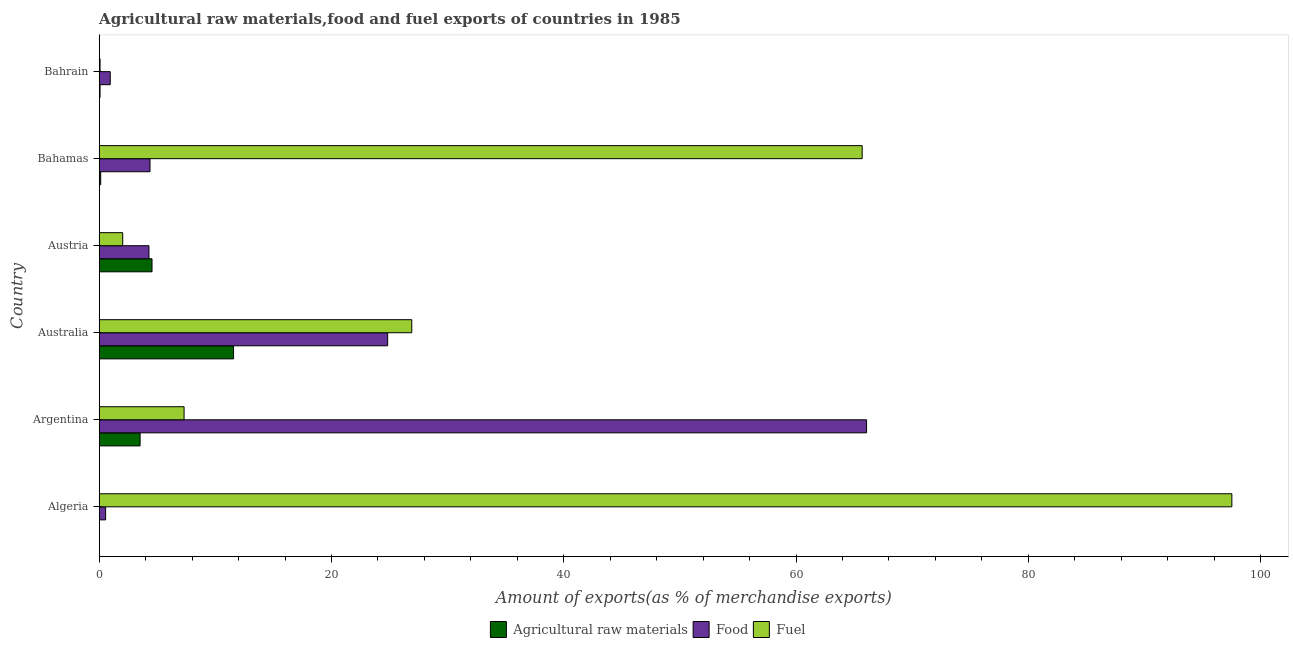How many bars are there on the 4th tick from the top?
Offer a terse response. 3. How many bars are there on the 4th tick from the bottom?
Offer a terse response. 3. What is the label of the 1st group of bars from the top?
Provide a short and direct response. Bahrain. What is the percentage of fuel exports in Australia?
Make the answer very short. 26.91. Across all countries, what is the maximum percentage of raw materials exports?
Your answer should be very brief. 11.57. Across all countries, what is the minimum percentage of raw materials exports?
Offer a terse response. 0.02. In which country was the percentage of fuel exports maximum?
Ensure brevity in your answer.  Algeria. In which country was the percentage of raw materials exports minimum?
Offer a terse response. Algeria. What is the total percentage of fuel exports in the graph?
Offer a very short reply. 199.53. What is the difference between the percentage of food exports in Australia and that in Bahrain?
Offer a very short reply. 23.89. What is the difference between the percentage of food exports in Argentina and the percentage of fuel exports in Bahamas?
Offer a terse response. 0.38. What is the average percentage of raw materials exports per country?
Make the answer very short. 3.31. What is the difference between the percentage of food exports and percentage of fuel exports in Algeria?
Ensure brevity in your answer.  -96.97. In how many countries, is the percentage of raw materials exports greater than 12 %?
Provide a succinct answer. 0. What is the ratio of the percentage of food exports in Bahamas to that in Bahrain?
Give a very brief answer. 4.61. What is the difference between the highest and the second highest percentage of raw materials exports?
Ensure brevity in your answer.  7.02. What is the difference between the highest and the lowest percentage of raw materials exports?
Your answer should be very brief. 11.55. What does the 2nd bar from the top in Argentina represents?
Make the answer very short. Food. What does the 3rd bar from the bottom in Algeria represents?
Your answer should be compact. Fuel. How many bars are there?
Offer a very short reply. 18. Are all the bars in the graph horizontal?
Provide a succinct answer. Yes. How many countries are there in the graph?
Offer a very short reply. 6. What is the difference between two consecutive major ticks on the X-axis?
Provide a short and direct response. 20. Are the values on the major ticks of X-axis written in scientific E-notation?
Provide a succinct answer. No. Does the graph contain any zero values?
Provide a short and direct response. No. Does the graph contain grids?
Give a very brief answer. No. What is the title of the graph?
Your answer should be very brief. Agricultural raw materials,food and fuel exports of countries in 1985. What is the label or title of the X-axis?
Offer a terse response. Amount of exports(as % of merchandise exports). What is the Amount of exports(as % of merchandise exports) of Agricultural raw materials in Algeria?
Offer a terse response. 0.02. What is the Amount of exports(as % of merchandise exports) in Food in Algeria?
Ensure brevity in your answer.  0.55. What is the Amount of exports(as % of merchandise exports) in Fuel in Algeria?
Give a very brief answer. 97.52. What is the Amount of exports(as % of merchandise exports) in Agricultural raw materials in Argentina?
Your answer should be very brief. 3.52. What is the Amount of exports(as % of merchandise exports) of Food in Argentina?
Keep it short and to the point. 66.07. What is the Amount of exports(as % of merchandise exports) of Fuel in Argentina?
Provide a short and direct response. 7.31. What is the Amount of exports(as % of merchandise exports) in Agricultural raw materials in Australia?
Offer a terse response. 11.57. What is the Amount of exports(as % of merchandise exports) in Food in Australia?
Offer a terse response. 24.83. What is the Amount of exports(as % of merchandise exports) of Fuel in Australia?
Make the answer very short. 26.91. What is the Amount of exports(as % of merchandise exports) in Agricultural raw materials in Austria?
Make the answer very short. 4.55. What is the Amount of exports(as % of merchandise exports) in Food in Austria?
Your response must be concise. 4.28. What is the Amount of exports(as % of merchandise exports) of Fuel in Austria?
Offer a very short reply. 2.02. What is the Amount of exports(as % of merchandise exports) in Agricultural raw materials in Bahamas?
Ensure brevity in your answer.  0.13. What is the Amount of exports(as % of merchandise exports) in Food in Bahamas?
Keep it short and to the point. 4.37. What is the Amount of exports(as % of merchandise exports) of Fuel in Bahamas?
Your answer should be compact. 65.69. What is the Amount of exports(as % of merchandise exports) of Agricultural raw materials in Bahrain?
Provide a succinct answer. 0.07. What is the Amount of exports(as % of merchandise exports) of Food in Bahrain?
Provide a succinct answer. 0.95. What is the Amount of exports(as % of merchandise exports) of Fuel in Bahrain?
Offer a very short reply. 0.07. Across all countries, what is the maximum Amount of exports(as % of merchandise exports) of Agricultural raw materials?
Offer a terse response. 11.57. Across all countries, what is the maximum Amount of exports(as % of merchandise exports) of Food?
Your response must be concise. 66.07. Across all countries, what is the maximum Amount of exports(as % of merchandise exports) of Fuel?
Provide a succinct answer. 97.52. Across all countries, what is the minimum Amount of exports(as % of merchandise exports) of Agricultural raw materials?
Offer a very short reply. 0.02. Across all countries, what is the minimum Amount of exports(as % of merchandise exports) in Food?
Keep it short and to the point. 0.55. Across all countries, what is the minimum Amount of exports(as % of merchandise exports) of Fuel?
Ensure brevity in your answer.  0.07. What is the total Amount of exports(as % of merchandise exports) in Agricultural raw materials in the graph?
Make the answer very short. 19.85. What is the total Amount of exports(as % of merchandise exports) of Food in the graph?
Offer a very short reply. 101.06. What is the total Amount of exports(as % of merchandise exports) in Fuel in the graph?
Provide a short and direct response. 199.53. What is the difference between the Amount of exports(as % of merchandise exports) of Agricultural raw materials in Algeria and that in Argentina?
Your answer should be compact. -3.5. What is the difference between the Amount of exports(as % of merchandise exports) in Food in Algeria and that in Argentina?
Offer a very short reply. -65.52. What is the difference between the Amount of exports(as % of merchandise exports) in Fuel in Algeria and that in Argentina?
Make the answer very short. 90.22. What is the difference between the Amount of exports(as % of merchandise exports) of Agricultural raw materials in Algeria and that in Australia?
Offer a very short reply. -11.55. What is the difference between the Amount of exports(as % of merchandise exports) of Food in Algeria and that in Australia?
Your answer should be compact. -24.28. What is the difference between the Amount of exports(as % of merchandise exports) of Fuel in Algeria and that in Australia?
Give a very brief answer. 70.61. What is the difference between the Amount of exports(as % of merchandise exports) in Agricultural raw materials in Algeria and that in Austria?
Offer a very short reply. -4.53. What is the difference between the Amount of exports(as % of merchandise exports) in Food in Algeria and that in Austria?
Make the answer very short. -3.73. What is the difference between the Amount of exports(as % of merchandise exports) in Fuel in Algeria and that in Austria?
Offer a very short reply. 95.5. What is the difference between the Amount of exports(as % of merchandise exports) in Agricultural raw materials in Algeria and that in Bahamas?
Ensure brevity in your answer.  -0.11. What is the difference between the Amount of exports(as % of merchandise exports) of Food in Algeria and that in Bahamas?
Give a very brief answer. -3.82. What is the difference between the Amount of exports(as % of merchandise exports) of Fuel in Algeria and that in Bahamas?
Keep it short and to the point. 31.83. What is the difference between the Amount of exports(as % of merchandise exports) of Agricultural raw materials in Algeria and that in Bahrain?
Provide a succinct answer. -0.05. What is the difference between the Amount of exports(as % of merchandise exports) in Food in Algeria and that in Bahrain?
Ensure brevity in your answer.  -0.4. What is the difference between the Amount of exports(as % of merchandise exports) in Fuel in Algeria and that in Bahrain?
Offer a terse response. 97.45. What is the difference between the Amount of exports(as % of merchandise exports) of Agricultural raw materials in Argentina and that in Australia?
Offer a very short reply. -8.05. What is the difference between the Amount of exports(as % of merchandise exports) in Food in Argentina and that in Australia?
Offer a terse response. 41.24. What is the difference between the Amount of exports(as % of merchandise exports) in Fuel in Argentina and that in Australia?
Offer a terse response. -19.6. What is the difference between the Amount of exports(as % of merchandise exports) in Agricultural raw materials in Argentina and that in Austria?
Provide a succinct answer. -1.03. What is the difference between the Amount of exports(as % of merchandise exports) of Food in Argentina and that in Austria?
Your answer should be very brief. 61.79. What is the difference between the Amount of exports(as % of merchandise exports) in Fuel in Argentina and that in Austria?
Give a very brief answer. 5.28. What is the difference between the Amount of exports(as % of merchandise exports) in Agricultural raw materials in Argentina and that in Bahamas?
Provide a short and direct response. 3.39. What is the difference between the Amount of exports(as % of merchandise exports) of Food in Argentina and that in Bahamas?
Your response must be concise. 61.7. What is the difference between the Amount of exports(as % of merchandise exports) of Fuel in Argentina and that in Bahamas?
Give a very brief answer. -58.39. What is the difference between the Amount of exports(as % of merchandise exports) of Agricultural raw materials in Argentina and that in Bahrain?
Your answer should be compact. 3.45. What is the difference between the Amount of exports(as % of merchandise exports) in Food in Argentina and that in Bahrain?
Ensure brevity in your answer.  65.12. What is the difference between the Amount of exports(as % of merchandise exports) in Fuel in Argentina and that in Bahrain?
Ensure brevity in your answer.  7.23. What is the difference between the Amount of exports(as % of merchandise exports) in Agricultural raw materials in Australia and that in Austria?
Your response must be concise. 7.02. What is the difference between the Amount of exports(as % of merchandise exports) in Food in Australia and that in Austria?
Provide a succinct answer. 20.55. What is the difference between the Amount of exports(as % of merchandise exports) in Fuel in Australia and that in Austria?
Your answer should be very brief. 24.89. What is the difference between the Amount of exports(as % of merchandise exports) in Agricultural raw materials in Australia and that in Bahamas?
Give a very brief answer. 11.44. What is the difference between the Amount of exports(as % of merchandise exports) in Food in Australia and that in Bahamas?
Provide a short and direct response. 20.46. What is the difference between the Amount of exports(as % of merchandise exports) of Fuel in Australia and that in Bahamas?
Your answer should be compact. -38.78. What is the difference between the Amount of exports(as % of merchandise exports) of Agricultural raw materials in Australia and that in Bahrain?
Your answer should be compact. 11.5. What is the difference between the Amount of exports(as % of merchandise exports) of Food in Australia and that in Bahrain?
Offer a terse response. 23.89. What is the difference between the Amount of exports(as % of merchandise exports) in Fuel in Australia and that in Bahrain?
Your response must be concise. 26.84. What is the difference between the Amount of exports(as % of merchandise exports) in Agricultural raw materials in Austria and that in Bahamas?
Your answer should be very brief. 4.42. What is the difference between the Amount of exports(as % of merchandise exports) in Food in Austria and that in Bahamas?
Offer a terse response. -0.09. What is the difference between the Amount of exports(as % of merchandise exports) of Fuel in Austria and that in Bahamas?
Your answer should be very brief. -63.67. What is the difference between the Amount of exports(as % of merchandise exports) of Agricultural raw materials in Austria and that in Bahrain?
Keep it short and to the point. 4.48. What is the difference between the Amount of exports(as % of merchandise exports) in Food in Austria and that in Bahrain?
Your answer should be very brief. 3.33. What is the difference between the Amount of exports(as % of merchandise exports) of Fuel in Austria and that in Bahrain?
Offer a very short reply. 1.95. What is the difference between the Amount of exports(as % of merchandise exports) in Agricultural raw materials in Bahamas and that in Bahrain?
Offer a terse response. 0.06. What is the difference between the Amount of exports(as % of merchandise exports) in Food in Bahamas and that in Bahrain?
Keep it short and to the point. 3.42. What is the difference between the Amount of exports(as % of merchandise exports) in Fuel in Bahamas and that in Bahrain?
Offer a very short reply. 65.62. What is the difference between the Amount of exports(as % of merchandise exports) of Agricultural raw materials in Algeria and the Amount of exports(as % of merchandise exports) of Food in Argentina?
Offer a very short reply. -66.05. What is the difference between the Amount of exports(as % of merchandise exports) of Agricultural raw materials in Algeria and the Amount of exports(as % of merchandise exports) of Fuel in Argentina?
Ensure brevity in your answer.  -7.29. What is the difference between the Amount of exports(as % of merchandise exports) in Food in Algeria and the Amount of exports(as % of merchandise exports) in Fuel in Argentina?
Make the answer very short. -6.76. What is the difference between the Amount of exports(as % of merchandise exports) in Agricultural raw materials in Algeria and the Amount of exports(as % of merchandise exports) in Food in Australia?
Your answer should be compact. -24.82. What is the difference between the Amount of exports(as % of merchandise exports) in Agricultural raw materials in Algeria and the Amount of exports(as % of merchandise exports) in Fuel in Australia?
Your answer should be very brief. -26.89. What is the difference between the Amount of exports(as % of merchandise exports) of Food in Algeria and the Amount of exports(as % of merchandise exports) of Fuel in Australia?
Provide a short and direct response. -26.36. What is the difference between the Amount of exports(as % of merchandise exports) in Agricultural raw materials in Algeria and the Amount of exports(as % of merchandise exports) in Food in Austria?
Your response must be concise. -4.27. What is the difference between the Amount of exports(as % of merchandise exports) in Agricultural raw materials in Algeria and the Amount of exports(as % of merchandise exports) in Fuel in Austria?
Offer a very short reply. -2.01. What is the difference between the Amount of exports(as % of merchandise exports) of Food in Algeria and the Amount of exports(as % of merchandise exports) of Fuel in Austria?
Keep it short and to the point. -1.47. What is the difference between the Amount of exports(as % of merchandise exports) of Agricultural raw materials in Algeria and the Amount of exports(as % of merchandise exports) of Food in Bahamas?
Your answer should be very brief. -4.36. What is the difference between the Amount of exports(as % of merchandise exports) of Agricultural raw materials in Algeria and the Amount of exports(as % of merchandise exports) of Fuel in Bahamas?
Keep it short and to the point. -65.68. What is the difference between the Amount of exports(as % of merchandise exports) in Food in Algeria and the Amount of exports(as % of merchandise exports) in Fuel in Bahamas?
Ensure brevity in your answer.  -65.14. What is the difference between the Amount of exports(as % of merchandise exports) in Agricultural raw materials in Algeria and the Amount of exports(as % of merchandise exports) in Food in Bahrain?
Make the answer very short. -0.93. What is the difference between the Amount of exports(as % of merchandise exports) in Agricultural raw materials in Algeria and the Amount of exports(as % of merchandise exports) in Fuel in Bahrain?
Give a very brief answer. -0.06. What is the difference between the Amount of exports(as % of merchandise exports) of Food in Algeria and the Amount of exports(as % of merchandise exports) of Fuel in Bahrain?
Give a very brief answer. 0.48. What is the difference between the Amount of exports(as % of merchandise exports) of Agricultural raw materials in Argentina and the Amount of exports(as % of merchandise exports) of Food in Australia?
Make the answer very short. -21.32. What is the difference between the Amount of exports(as % of merchandise exports) in Agricultural raw materials in Argentina and the Amount of exports(as % of merchandise exports) in Fuel in Australia?
Give a very brief answer. -23.39. What is the difference between the Amount of exports(as % of merchandise exports) in Food in Argentina and the Amount of exports(as % of merchandise exports) in Fuel in Australia?
Provide a short and direct response. 39.16. What is the difference between the Amount of exports(as % of merchandise exports) of Agricultural raw materials in Argentina and the Amount of exports(as % of merchandise exports) of Food in Austria?
Give a very brief answer. -0.77. What is the difference between the Amount of exports(as % of merchandise exports) of Agricultural raw materials in Argentina and the Amount of exports(as % of merchandise exports) of Fuel in Austria?
Your answer should be very brief. 1.5. What is the difference between the Amount of exports(as % of merchandise exports) of Food in Argentina and the Amount of exports(as % of merchandise exports) of Fuel in Austria?
Make the answer very short. 64.05. What is the difference between the Amount of exports(as % of merchandise exports) in Agricultural raw materials in Argentina and the Amount of exports(as % of merchandise exports) in Food in Bahamas?
Make the answer very short. -0.85. What is the difference between the Amount of exports(as % of merchandise exports) of Agricultural raw materials in Argentina and the Amount of exports(as % of merchandise exports) of Fuel in Bahamas?
Provide a succinct answer. -62.17. What is the difference between the Amount of exports(as % of merchandise exports) in Food in Argentina and the Amount of exports(as % of merchandise exports) in Fuel in Bahamas?
Your response must be concise. 0.38. What is the difference between the Amount of exports(as % of merchandise exports) of Agricultural raw materials in Argentina and the Amount of exports(as % of merchandise exports) of Food in Bahrain?
Offer a terse response. 2.57. What is the difference between the Amount of exports(as % of merchandise exports) in Agricultural raw materials in Argentina and the Amount of exports(as % of merchandise exports) in Fuel in Bahrain?
Your answer should be very brief. 3.45. What is the difference between the Amount of exports(as % of merchandise exports) in Food in Argentina and the Amount of exports(as % of merchandise exports) in Fuel in Bahrain?
Provide a short and direct response. 66. What is the difference between the Amount of exports(as % of merchandise exports) of Agricultural raw materials in Australia and the Amount of exports(as % of merchandise exports) of Food in Austria?
Give a very brief answer. 7.28. What is the difference between the Amount of exports(as % of merchandise exports) of Agricultural raw materials in Australia and the Amount of exports(as % of merchandise exports) of Fuel in Austria?
Give a very brief answer. 9.55. What is the difference between the Amount of exports(as % of merchandise exports) of Food in Australia and the Amount of exports(as % of merchandise exports) of Fuel in Austria?
Offer a very short reply. 22.81. What is the difference between the Amount of exports(as % of merchandise exports) in Agricultural raw materials in Australia and the Amount of exports(as % of merchandise exports) in Food in Bahamas?
Offer a terse response. 7.19. What is the difference between the Amount of exports(as % of merchandise exports) in Agricultural raw materials in Australia and the Amount of exports(as % of merchandise exports) in Fuel in Bahamas?
Keep it short and to the point. -54.12. What is the difference between the Amount of exports(as % of merchandise exports) in Food in Australia and the Amount of exports(as % of merchandise exports) in Fuel in Bahamas?
Your answer should be very brief. -40.86. What is the difference between the Amount of exports(as % of merchandise exports) of Agricultural raw materials in Australia and the Amount of exports(as % of merchandise exports) of Food in Bahrain?
Make the answer very short. 10.62. What is the difference between the Amount of exports(as % of merchandise exports) of Agricultural raw materials in Australia and the Amount of exports(as % of merchandise exports) of Fuel in Bahrain?
Make the answer very short. 11.49. What is the difference between the Amount of exports(as % of merchandise exports) of Food in Australia and the Amount of exports(as % of merchandise exports) of Fuel in Bahrain?
Your answer should be very brief. 24.76. What is the difference between the Amount of exports(as % of merchandise exports) in Agricultural raw materials in Austria and the Amount of exports(as % of merchandise exports) in Food in Bahamas?
Keep it short and to the point. 0.17. What is the difference between the Amount of exports(as % of merchandise exports) of Agricultural raw materials in Austria and the Amount of exports(as % of merchandise exports) of Fuel in Bahamas?
Give a very brief answer. -61.15. What is the difference between the Amount of exports(as % of merchandise exports) in Food in Austria and the Amount of exports(as % of merchandise exports) in Fuel in Bahamas?
Give a very brief answer. -61.41. What is the difference between the Amount of exports(as % of merchandise exports) in Agricultural raw materials in Austria and the Amount of exports(as % of merchandise exports) in Food in Bahrain?
Make the answer very short. 3.6. What is the difference between the Amount of exports(as % of merchandise exports) of Agricultural raw materials in Austria and the Amount of exports(as % of merchandise exports) of Fuel in Bahrain?
Your response must be concise. 4.47. What is the difference between the Amount of exports(as % of merchandise exports) of Food in Austria and the Amount of exports(as % of merchandise exports) of Fuel in Bahrain?
Provide a short and direct response. 4.21. What is the difference between the Amount of exports(as % of merchandise exports) in Agricultural raw materials in Bahamas and the Amount of exports(as % of merchandise exports) in Food in Bahrain?
Your answer should be compact. -0.82. What is the difference between the Amount of exports(as % of merchandise exports) of Agricultural raw materials in Bahamas and the Amount of exports(as % of merchandise exports) of Fuel in Bahrain?
Your response must be concise. 0.05. What is the average Amount of exports(as % of merchandise exports) of Agricultural raw materials per country?
Offer a terse response. 3.31. What is the average Amount of exports(as % of merchandise exports) of Food per country?
Your answer should be compact. 16.84. What is the average Amount of exports(as % of merchandise exports) of Fuel per country?
Your answer should be compact. 33.25. What is the difference between the Amount of exports(as % of merchandise exports) in Agricultural raw materials and Amount of exports(as % of merchandise exports) in Food in Algeria?
Provide a short and direct response. -0.53. What is the difference between the Amount of exports(as % of merchandise exports) of Agricultural raw materials and Amount of exports(as % of merchandise exports) of Fuel in Algeria?
Ensure brevity in your answer.  -97.51. What is the difference between the Amount of exports(as % of merchandise exports) in Food and Amount of exports(as % of merchandise exports) in Fuel in Algeria?
Provide a succinct answer. -96.97. What is the difference between the Amount of exports(as % of merchandise exports) in Agricultural raw materials and Amount of exports(as % of merchandise exports) in Food in Argentina?
Keep it short and to the point. -62.55. What is the difference between the Amount of exports(as % of merchandise exports) in Agricultural raw materials and Amount of exports(as % of merchandise exports) in Fuel in Argentina?
Your answer should be very brief. -3.79. What is the difference between the Amount of exports(as % of merchandise exports) in Food and Amount of exports(as % of merchandise exports) in Fuel in Argentina?
Provide a short and direct response. 58.76. What is the difference between the Amount of exports(as % of merchandise exports) of Agricultural raw materials and Amount of exports(as % of merchandise exports) of Food in Australia?
Your answer should be compact. -13.27. What is the difference between the Amount of exports(as % of merchandise exports) of Agricultural raw materials and Amount of exports(as % of merchandise exports) of Fuel in Australia?
Offer a terse response. -15.34. What is the difference between the Amount of exports(as % of merchandise exports) in Food and Amount of exports(as % of merchandise exports) in Fuel in Australia?
Ensure brevity in your answer.  -2.08. What is the difference between the Amount of exports(as % of merchandise exports) in Agricultural raw materials and Amount of exports(as % of merchandise exports) in Food in Austria?
Offer a terse response. 0.26. What is the difference between the Amount of exports(as % of merchandise exports) in Agricultural raw materials and Amount of exports(as % of merchandise exports) in Fuel in Austria?
Provide a short and direct response. 2.52. What is the difference between the Amount of exports(as % of merchandise exports) of Food and Amount of exports(as % of merchandise exports) of Fuel in Austria?
Your response must be concise. 2.26. What is the difference between the Amount of exports(as % of merchandise exports) of Agricultural raw materials and Amount of exports(as % of merchandise exports) of Food in Bahamas?
Your answer should be compact. -4.25. What is the difference between the Amount of exports(as % of merchandise exports) of Agricultural raw materials and Amount of exports(as % of merchandise exports) of Fuel in Bahamas?
Offer a terse response. -65.57. What is the difference between the Amount of exports(as % of merchandise exports) in Food and Amount of exports(as % of merchandise exports) in Fuel in Bahamas?
Your answer should be compact. -61.32. What is the difference between the Amount of exports(as % of merchandise exports) in Agricultural raw materials and Amount of exports(as % of merchandise exports) in Food in Bahrain?
Your answer should be compact. -0.88. What is the difference between the Amount of exports(as % of merchandise exports) in Agricultural raw materials and Amount of exports(as % of merchandise exports) in Fuel in Bahrain?
Your answer should be very brief. -0. What is the difference between the Amount of exports(as % of merchandise exports) of Food and Amount of exports(as % of merchandise exports) of Fuel in Bahrain?
Give a very brief answer. 0.88. What is the ratio of the Amount of exports(as % of merchandise exports) of Agricultural raw materials in Algeria to that in Argentina?
Give a very brief answer. 0. What is the ratio of the Amount of exports(as % of merchandise exports) in Food in Algeria to that in Argentina?
Provide a short and direct response. 0.01. What is the ratio of the Amount of exports(as % of merchandise exports) of Fuel in Algeria to that in Argentina?
Provide a short and direct response. 13.35. What is the ratio of the Amount of exports(as % of merchandise exports) of Agricultural raw materials in Algeria to that in Australia?
Provide a succinct answer. 0. What is the ratio of the Amount of exports(as % of merchandise exports) in Food in Algeria to that in Australia?
Your response must be concise. 0.02. What is the ratio of the Amount of exports(as % of merchandise exports) in Fuel in Algeria to that in Australia?
Your response must be concise. 3.62. What is the ratio of the Amount of exports(as % of merchandise exports) of Agricultural raw materials in Algeria to that in Austria?
Ensure brevity in your answer.  0. What is the ratio of the Amount of exports(as % of merchandise exports) in Food in Algeria to that in Austria?
Provide a short and direct response. 0.13. What is the ratio of the Amount of exports(as % of merchandise exports) of Fuel in Algeria to that in Austria?
Provide a succinct answer. 48.22. What is the ratio of the Amount of exports(as % of merchandise exports) in Agricultural raw materials in Algeria to that in Bahamas?
Offer a very short reply. 0.13. What is the ratio of the Amount of exports(as % of merchandise exports) of Food in Algeria to that in Bahamas?
Your response must be concise. 0.13. What is the ratio of the Amount of exports(as % of merchandise exports) in Fuel in Algeria to that in Bahamas?
Your response must be concise. 1.48. What is the ratio of the Amount of exports(as % of merchandise exports) of Agricultural raw materials in Algeria to that in Bahrain?
Provide a succinct answer. 0.23. What is the ratio of the Amount of exports(as % of merchandise exports) of Food in Algeria to that in Bahrain?
Give a very brief answer. 0.58. What is the ratio of the Amount of exports(as % of merchandise exports) in Fuel in Algeria to that in Bahrain?
Provide a succinct answer. 1343.03. What is the ratio of the Amount of exports(as % of merchandise exports) of Agricultural raw materials in Argentina to that in Australia?
Offer a terse response. 0.3. What is the ratio of the Amount of exports(as % of merchandise exports) in Food in Argentina to that in Australia?
Your answer should be very brief. 2.66. What is the ratio of the Amount of exports(as % of merchandise exports) of Fuel in Argentina to that in Australia?
Offer a very short reply. 0.27. What is the ratio of the Amount of exports(as % of merchandise exports) of Agricultural raw materials in Argentina to that in Austria?
Provide a short and direct response. 0.77. What is the ratio of the Amount of exports(as % of merchandise exports) of Food in Argentina to that in Austria?
Provide a succinct answer. 15.42. What is the ratio of the Amount of exports(as % of merchandise exports) in Fuel in Argentina to that in Austria?
Keep it short and to the point. 3.61. What is the ratio of the Amount of exports(as % of merchandise exports) in Agricultural raw materials in Argentina to that in Bahamas?
Your answer should be compact. 27.75. What is the ratio of the Amount of exports(as % of merchandise exports) of Food in Argentina to that in Bahamas?
Ensure brevity in your answer.  15.11. What is the ratio of the Amount of exports(as % of merchandise exports) of Fuel in Argentina to that in Bahamas?
Make the answer very short. 0.11. What is the ratio of the Amount of exports(as % of merchandise exports) of Agricultural raw materials in Argentina to that in Bahrain?
Ensure brevity in your answer.  49.51. What is the ratio of the Amount of exports(as % of merchandise exports) of Food in Argentina to that in Bahrain?
Provide a succinct answer. 69.6. What is the ratio of the Amount of exports(as % of merchandise exports) of Fuel in Argentina to that in Bahrain?
Provide a succinct answer. 100.63. What is the ratio of the Amount of exports(as % of merchandise exports) in Agricultural raw materials in Australia to that in Austria?
Your answer should be compact. 2.54. What is the ratio of the Amount of exports(as % of merchandise exports) of Food in Australia to that in Austria?
Your answer should be very brief. 5.8. What is the ratio of the Amount of exports(as % of merchandise exports) of Fuel in Australia to that in Austria?
Offer a terse response. 13.31. What is the ratio of the Amount of exports(as % of merchandise exports) of Agricultural raw materials in Australia to that in Bahamas?
Your answer should be very brief. 91.23. What is the ratio of the Amount of exports(as % of merchandise exports) in Food in Australia to that in Bahamas?
Your answer should be compact. 5.68. What is the ratio of the Amount of exports(as % of merchandise exports) of Fuel in Australia to that in Bahamas?
Offer a very short reply. 0.41. What is the ratio of the Amount of exports(as % of merchandise exports) in Agricultural raw materials in Australia to that in Bahrain?
Make the answer very short. 162.76. What is the ratio of the Amount of exports(as % of merchandise exports) in Food in Australia to that in Bahrain?
Your answer should be very brief. 26.16. What is the ratio of the Amount of exports(as % of merchandise exports) in Fuel in Australia to that in Bahrain?
Offer a very short reply. 370.61. What is the ratio of the Amount of exports(as % of merchandise exports) in Agricultural raw materials in Austria to that in Bahamas?
Your response must be concise. 35.86. What is the ratio of the Amount of exports(as % of merchandise exports) of Food in Austria to that in Bahamas?
Provide a short and direct response. 0.98. What is the ratio of the Amount of exports(as % of merchandise exports) in Fuel in Austria to that in Bahamas?
Your answer should be compact. 0.03. What is the ratio of the Amount of exports(as % of merchandise exports) of Agricultural raw materials in Austria to that in Bahrain?
Ensure brevity in your answer.  63.98. What is the ratio of the Amount of exports(as % of merchandise exports) in Food in Austria to that in Bahrain?
Your answer should be very brief. 4.51. What is the ratio of the Amount of exports(as % of merchandise exports) in Fuel in Austria to that in Bahrain?
Keep it short and to the point. 27.85. What is the ratio of the Amount of exports(as % of merchandise exports) of Agricultural raw materials in Bahamas to that in Bahrain?
Offer a terse response. 1.78. What is the ratio of the Amount of exports(as % of merchandise exports) of Food in Bahamas to that in Bahrain?
Your answer should be compact. 4.61. What is the ratio of the Amount of exports(as % of merchandise exports) in Fuel in Bahamas to that in Bahrain?
Provide a succinct answer. 904.68. What is the difference between the highest and the second highest Amount of exports(as % of merchandise exports) of Agricultural raw materials?
Your answer should be very brief. 7.02. What is the difference between the highest and the second highest Amount of exports(as % of merchandise exports) of Food?
Your answer should be compact. 41.24. What is the difference between the highest and the second highest Amount of exports(as % of merchandise exports) in Fuel?
Your answer should be very brief. 31.83. What is the difference between the highest and the lowest Amount of exports(as % of merchandise exports) in Agricultural raw materials?
Offer a very short reply. 11.55. What is the difference between the highest and the lowest Amount of exports(as % of merchandise exports) of Food?
Provide a short and direct response. 65.52. What is the difference between the highest and the lowest Amount of exports(as % of merchandise exports) of Fuel?
Offer a very short reply. 97.45. 